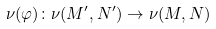<formula> <loc_0><loc_0><loc_500><loc_500>\nu ( \varphi ) \colon \nu ( M ^ { \prime } , N ^ { \prime } ) \to \nu ( M , N )</formula> 